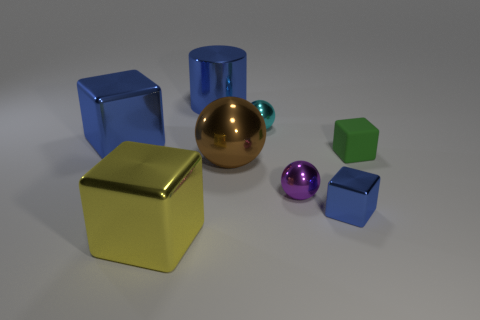There is a tiny thing that is the same color as the big cylinder; what is it made of?
Keep it short and to the point. Metal. Is the shape of the blue thing to the right of the cyan metal object the same as  the large yellow thing?
Make the answer very short. Yes. What number of things are purple rubber spheres or large blue objects that are left of the blue metal cylinder?
Offer a very short reply. 1. Is the material of the large cube that is behind the brown object the same as the green object?
Your answer should be compact. No. What material is the blue object behind the blue shiny cube on the left side of the large brown shiny ball?
Provide a succinct answer. Metal. Are there more blue metal blocks behind the large yellow metal object than small matte cubes in front of the purple shiny ball?
Ensure brevity in your answer.  Yes. The yellow shiny block is what size?
Ensure brevity in your answer.  Large. Does the metallic object that is behind the tiny cyan thing have the same color as the tiny metal cube?
Provide a short and direct response. Yes. There is a small thing behind the tiny green block; are there any big brown metallic objects that are behind it?
Your answer should be compact. No. Are there fewer large metal spheres that are behind the tiny cyan ball than shiny cubes that are on the left side of the purple shiny object?
Provide a short and direct response. Yes. 